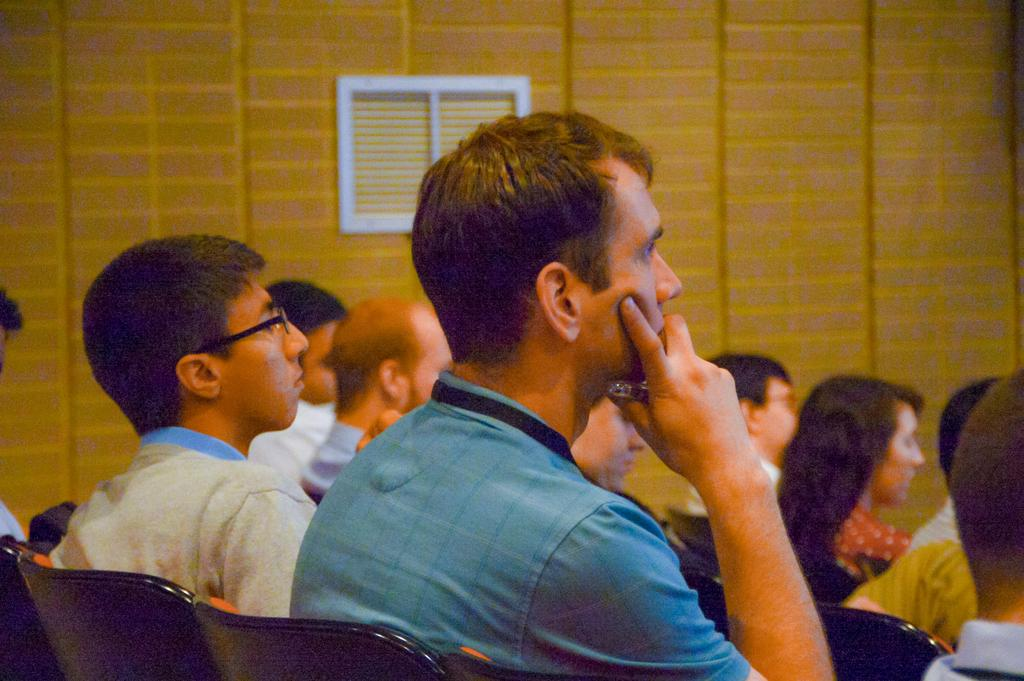What are the people in the image doing? The people in the image are sitting on chairs. What can be seen in the background of the image? There is a yellow wall in the background of the image. What is the name of the person sitting on the chair in the image? There is no specific person mentioned in the image, so it is not possible to determine their name. 